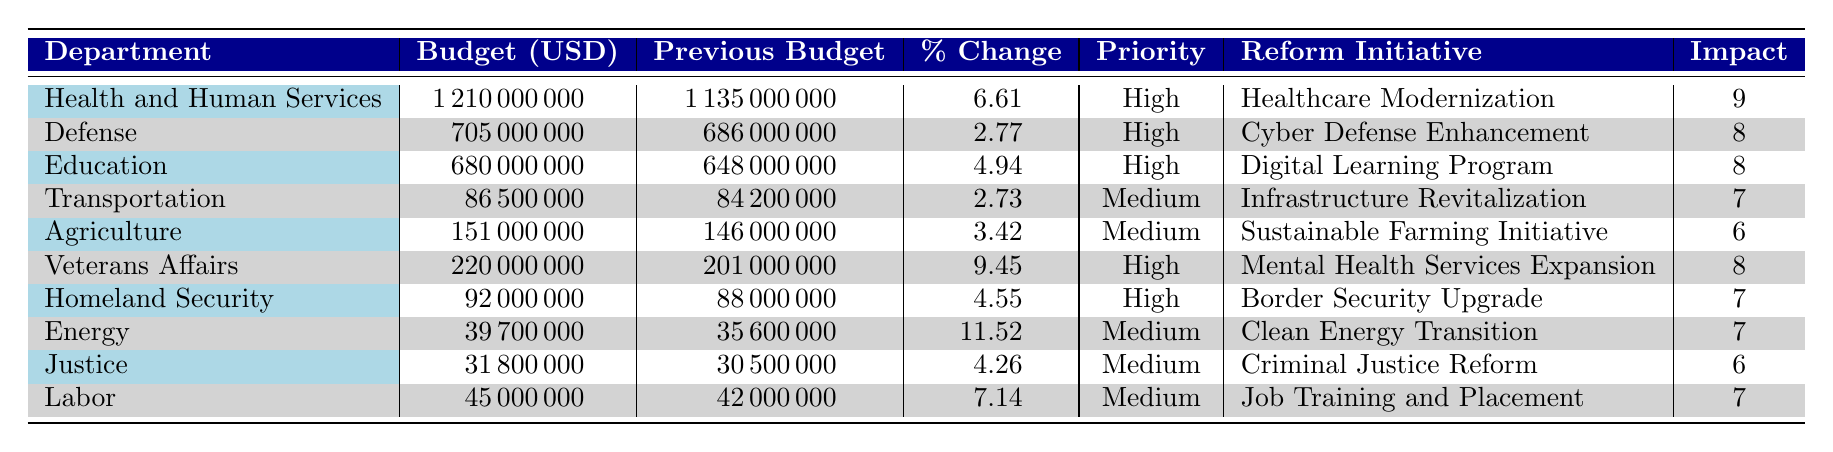What is the budget allocation for Health and Human Services? The budget allocation listed under Health and Human Services is 1,210,000,000 USD.
Answer: 1,210,000,000 Which department has the highest estimated impact score? The department with the highest estimated impact score is Health and Human Services, with a score of 9.
Answer: Health and Human Services What is the total budget allocation across all departments? The total budget allocation can be found by summing the individual budgets: 1,210,000,000 + 705,000,000 + 680,000,000 + 86,500,000 + 151,000,000 + 220,000,000 + 92,000,000 + 39,700,000 + 31,800,000 + 45,000,000 = 3,210,000,000 USD.
Answer: 3,210,000,000 Is there a budget increase for Transportation compared to the previous year? The budget for Transportation this year is 86,500,000 USD, compared to 84,200,000 USD last year. Since the new budget is higher, there is an increase.
Answer: Yes What is the percent change in budget allocation for Veterans Affairs? For Veterans Affairs, the previous budget was 201,000,000 USD and the new budget is 220,000,000 USD. The percent change is calculated as ((220,000,000 - 201,000,000) / 201,000,000) * 100 = 9.45%.
Answer: 9.45 How many departments have a budget allocation of over 500 million USD? Looking at the budget allocations, only Health and Human Services (1,210,000,000 USD) and Defense (705,000,000 USD) are over 500 million USD, which sums to 2 departments.
Answer: 2 What is the average estimated impact score for departments with a high priority level? The departments with a high priority level and their impact scores are Health and Human Services (9), Defense (8), Education (8), Veterans Affairs (8), and Homeland Security (7). The average is calculated as (9 + 8 + 8 + 8 + 7) / 5 = 8. The average estimated impact score for high priority departments is 8.
Answer: 8 Which department experienced the lowest percent change in budget allocation? Reviewing the percent changes, the lowest change is 2.73% for the Transportation department.
Answer: Transportation Does the Agriculture department have a higher budget than the Labor department? The Agriculture department's budget is 151,000,000 USD and Labor's budget is 45,000,000 USD. Since 151,000,000 > 45,000,000, Agriculture has a higher budget.
Answer: Yes What is the total budget allocation for departments categorized as medium priority? The departments with medium priority and their budget allocations are Transportation (86,500,000), Agriculture (151,000,000), Energy (39,700,000), Justice (31,800,000), and Labor (45,000,000). Adding these values gives 86,500,000 + 151,000,000 + 39,700,000 + 31,800,000 + 45,000,000 = 354,000,000 USD.
Answer: 354,000,000 